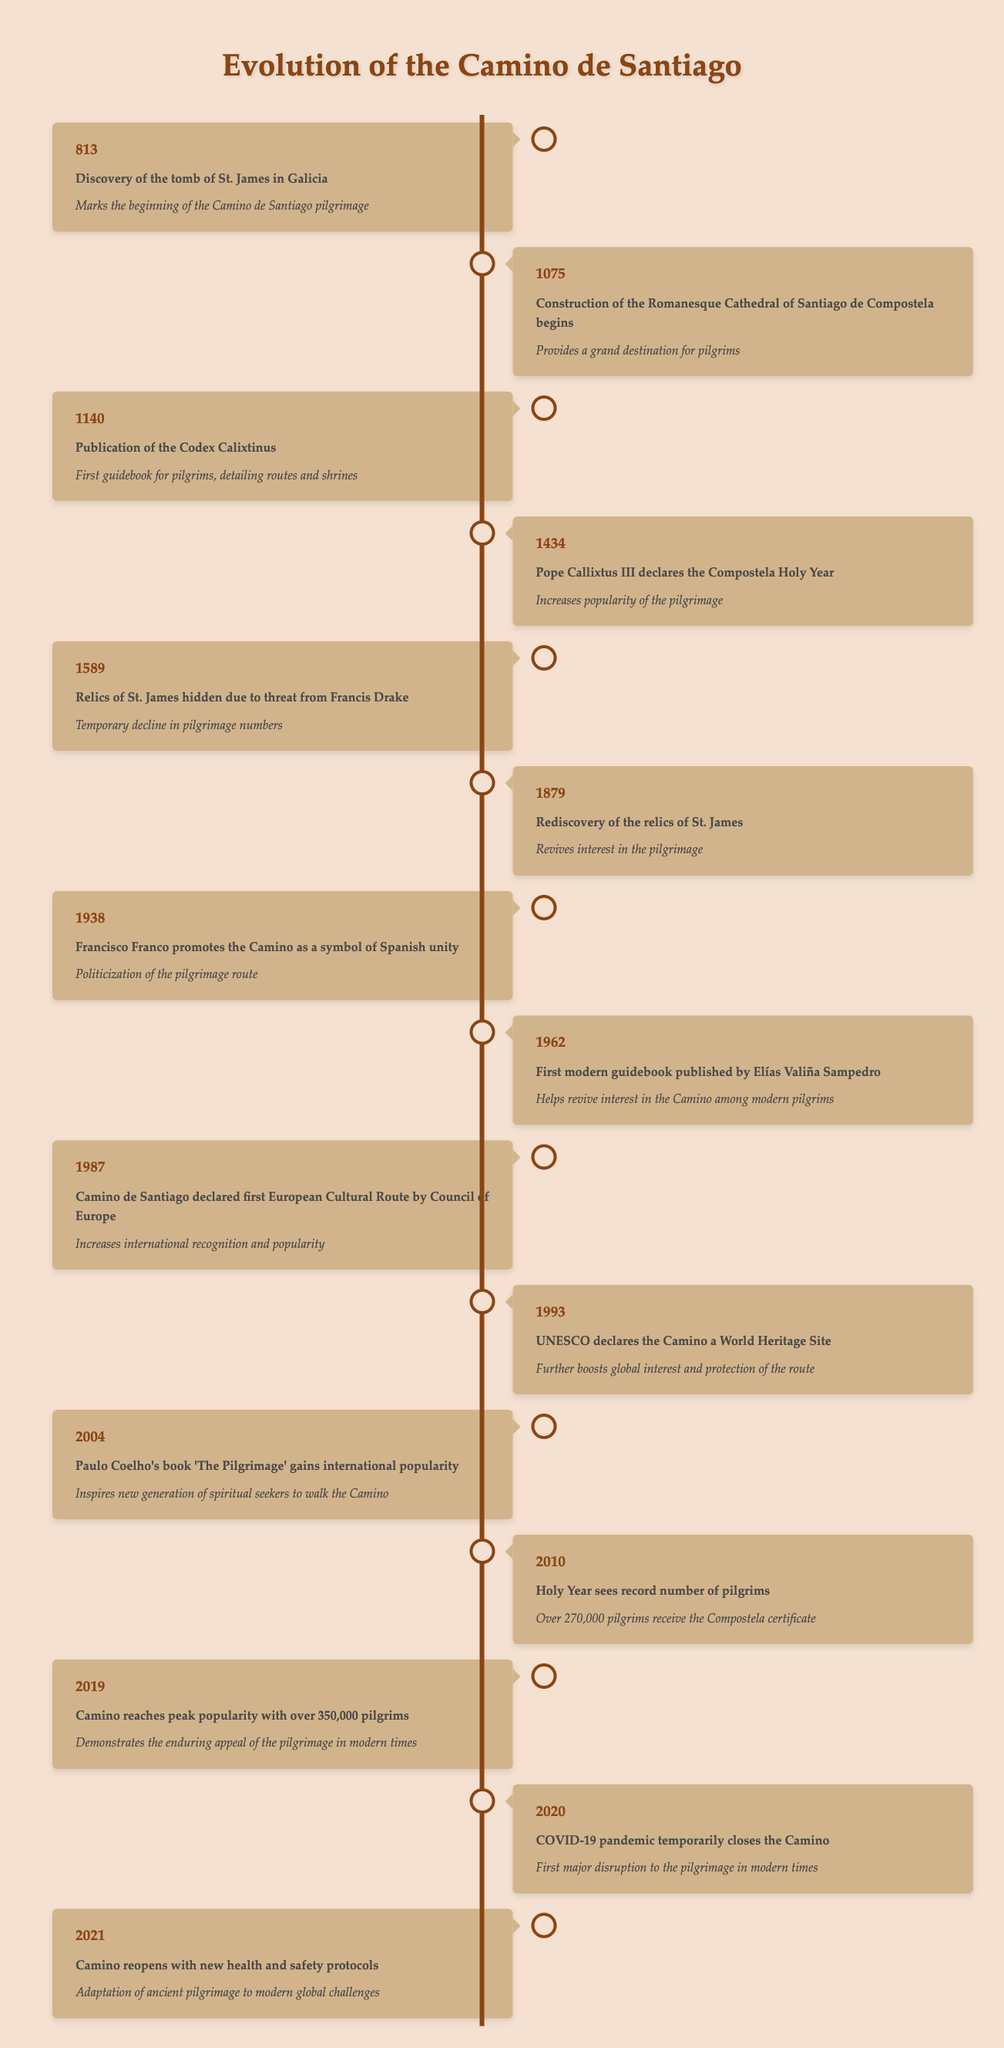What year marks the beginning of the Camino de Santiago pilgrimage? The table indicates that the discovery of the tomb of St. James in Galicia occurred in the year 813, which is identified as the starting point of the pilgrimage.
Answer: 813 What significant event took place in 1434 related to the Camino de Santiago? In 1434, Pope Callixtus III declared the Compostela Holy Year, which is noted in the table for increasing the pilgrimage's popularity.
Answer: Declaration of the Compostela Holy Year During which year was the first modern guidebook for pilgrims published? According to the table, the first modern guidebook was published by Elías Valiña Sampedro in 1962.
Answer: 1962 How many pilgrims received the Compostela certificate in 2010? The table specifies that during the Holy Year of 2010, over 270,000 pilgrims received the Compostela certificate, which indicates significant participation during that year.
Answer: Over 270,000 Did the Camino de Santiago experience a resurgence after 1879? Yes, the table states that the rediscovery of the relics of St. James in 1879 revived interest in the pilgrimage, suggesting a positive trend following that year.
Answer: Yes What was the peak year for pilgrimage numbers, and how many pilgrims participated? The table shows that in 2019, the Camino reached its peak popularity with over 350,000 pilgrims, indicating a successful culmination of interest in the pilgrimage.
Answer: 2019; over 350,000 How many years elapsed between the declaration of the Camino as a World Heritage Site and its designation as a European Cultural Route? The declaration as a World Heritage Site occurred in 1993, and the designation as a European Cultural Route was in 1987. The elapsed years can be calculated as 1993 - 1987 = 6 years.
Answer: 6 years What was the impact of the COVID-19 pandemic on the Camino? The table notes that the COVID-19 pandemic temporarily closed the Camino in 2020, marking it as the first major disruption to the pilgrimage in modern times.
Answer: Temporary closure What change occurred on the Camino in 2021? The table indicates that in 2021, the Camino reopened with new health and safety protocols, showing an adaptation to contemporary challenges following the pandemic.
Answer: Reopened with new health protocols 